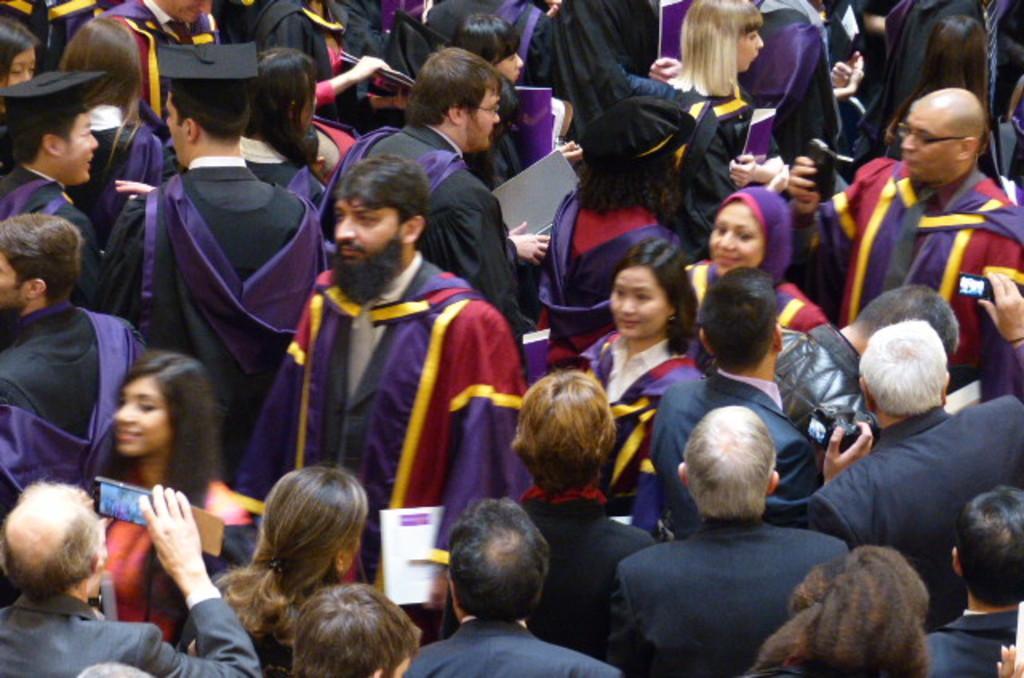Describe this image in one or two sentences. In this picture we can see a group of people and some people are holding files, some people are holding devices. 